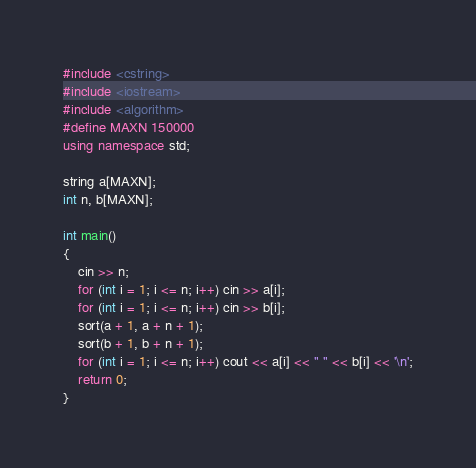<code> <loc_0><loc_0><loc_500><loc_500><_C++_>#include <cstring>
#include <iostream>
#include <algorithm>
#define MAXN 150000
using namespace std;

string a[MAXN];
int n, b[MAXN];

int main()
{
	cin >> n;
	for (int i = 1; i <= n; i++) cin >> a[i];
	for (int i = 1; i <= n; i++) cin >> b[i];
	sort(a + 1, a + n + 1);
	sort(b + 1, b + n + 1);
	for (int i = 1; i <= n; i++) cout << a[i] << " " << b[i] << '\n';
	return 0;
}</code> 